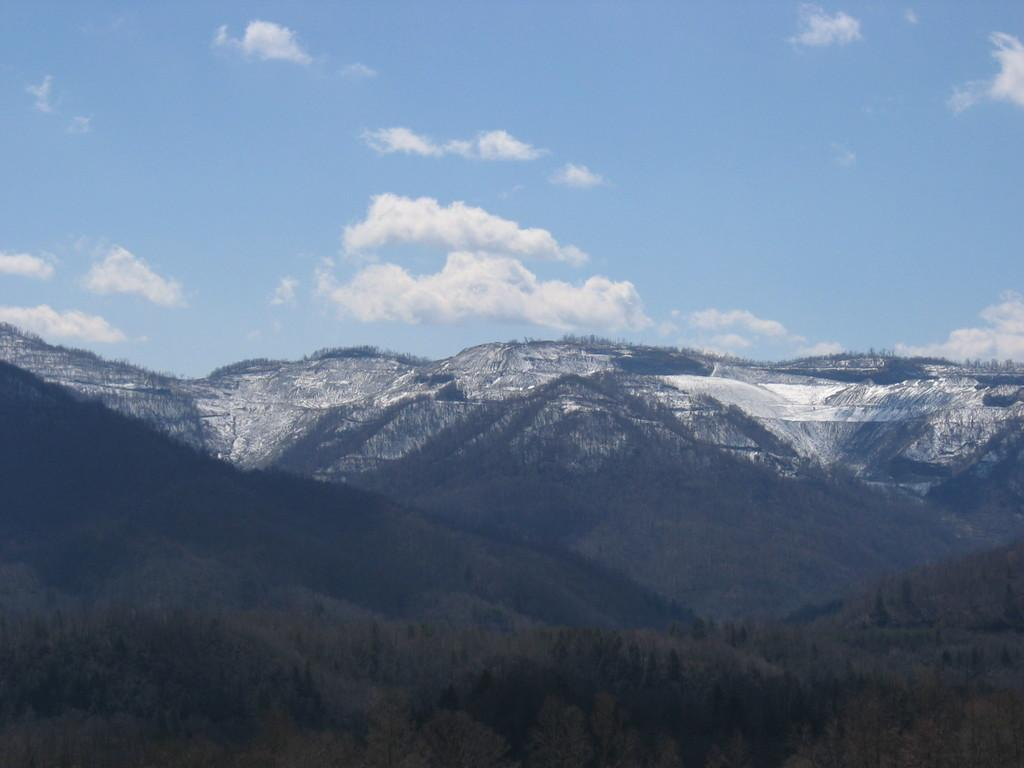What type of natural features can be seen in the image? There are trees and mountains in the image. What is the condition of the sky in the image? The sky is cloudy in the image. What type of weather is suggested by the presence of snow in the image? The presence of snow suggests cold weather in the image. Can you see a couple kissing in the image? There is no couple or any indication of a kiss in the image. How many people are asking for help in the image? There are no people asking for help in the image. 